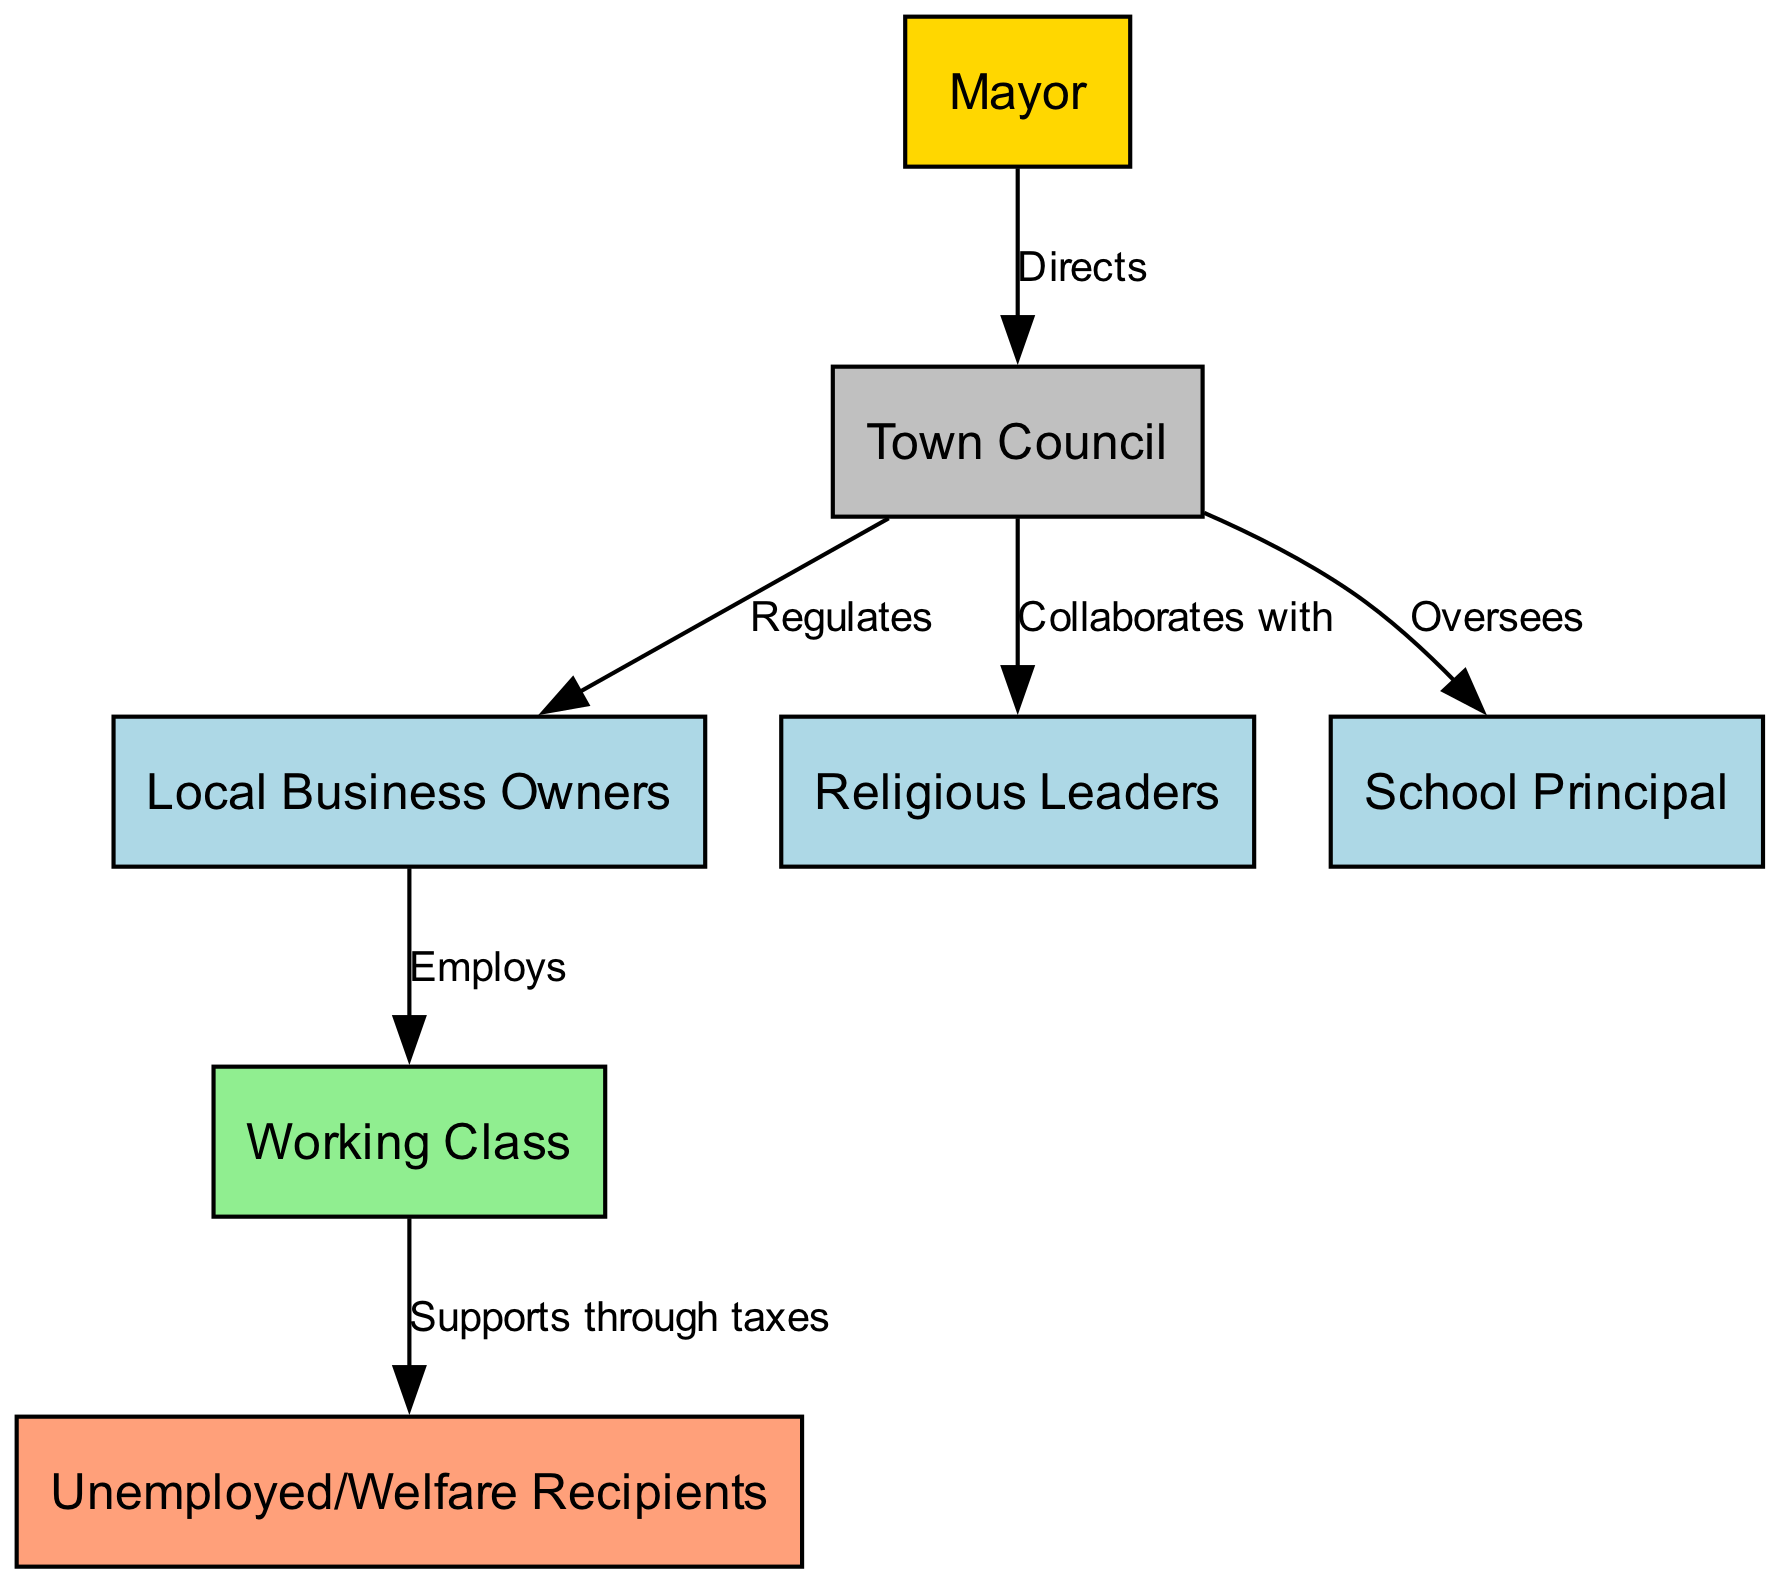What is the top node in the hierarchy? The diagram shows a single top node labeled "Mayor", which is at the highest level of the social hierarchy within the community.
Answer: Mayor How many nodes are there in total? The diagram contains 7 distinct nodes, each representing different roles within the social hierarchy of the town community.
Answer: 7 What is the relationship between the Town Council and Local Business Owners? According to the edges in the diagram, the Town Council "Regulates" the Local Business Owners, indicating a governance relationship where the Town Council has authority over business activities.
Answer: Regulates Which node directly employs the Working Class? The Local Business Owners are shown to directly "Employ" the Working Class in the diagram, establishing a clear link in this social structure regarding employment.
Answer: Local Business Owners Who does the Working Class support through taxes? The diagram illustrates that the Working Class "Supports through taxes" the Unemployed/Welfare Recipients, highlighting a flow of financial support within the social framework.
Answer: Unemployed/Welfare Recipients What color represents the Mayor in this diagram? The Mayor is represented in yellow (specifically the color code #FFD700) in the diagram, distinguishing this high-status node from others in the social structure.
Answer: Yellow How many edges connect the Town Council to other nodes? The Town Council has three edges connecting it to other nodes, representing various relationships it has with the Local Business Owners, Religious Leaders, and School Principal.
Answer: 3 What is the role of the School Principal in relation to the Town Council? The diagram indicates that the Town Council "Oversees" the School Principal, which implies a supervisory relationship.
Answer: Oversees What type of relationship exists between the Town Council and Religious Leaders? The diagram states that the Town Council "Collaborates with" Religious Leaders, denoting a cooperative relationship between the two entities.
Answer: Collaborates with 